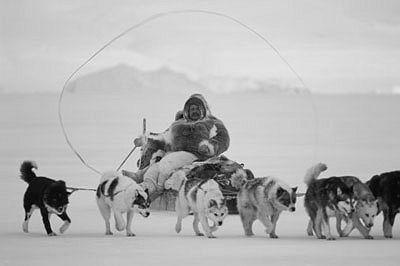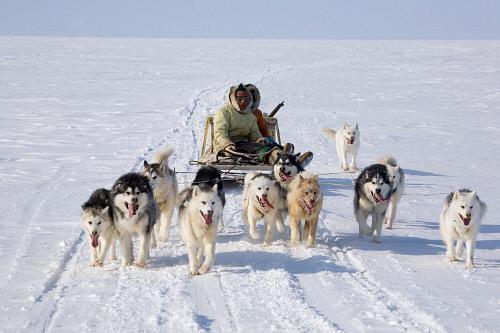The first image is the image on the left, the second image is the image on the right. For the images shown, is this caption "All the dogs are moving forward." true? Answer yes or no. Yes. 